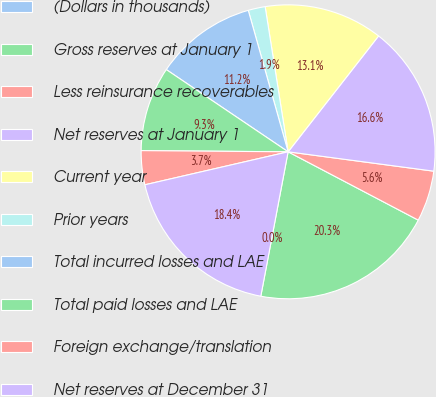Convert chart to OTSL. <chart><loc_0><loc_0><loc_500><loc_500><pie_chart><fcel>(Dollars in thousands)<fcel>Gross reserves at January 1<fcel>Less reinsurance recoverables<fcel>Net reserves at January 1<fcel>Current year<fcel>Prior years<fcel>Total incurred losses and LAE<fcel>Total paid losses and LAE<fcel>Foreign exchange/translation<fcel>Net reserves at December 31<nl><fcel>0.0%<fcel>20.28%<fcel>5.59%<fcel>16.55%<fcel>13.05%<fcel>1.87%<fcel>11.18%<fcel>9.32%<fcel>3.73%<fcel>18.42%<nl></chart> 